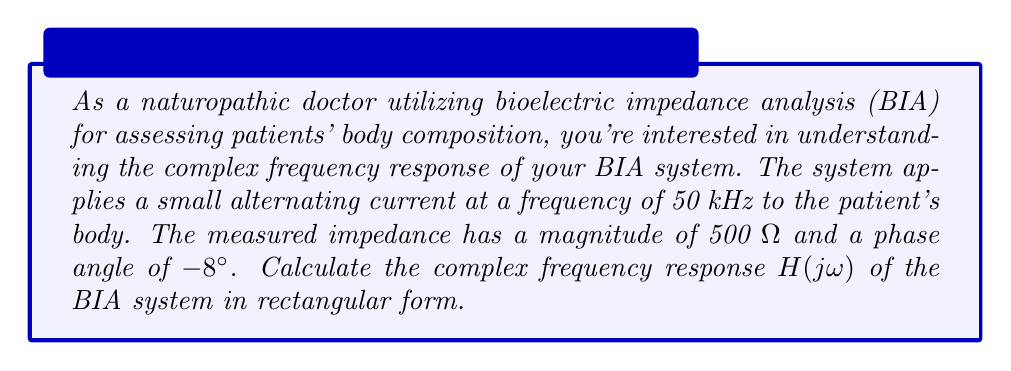Provide a solution to this math problem. To solve this problem, we'll follow these steps:

1) The complex frequency response H(jω) is essentially the same as the measured impedance in this case.

2) We're given the magnitude and phase angle of the impedance. This is in polar form, and we need to convert it to rectangular form.

3) The general form for converting from polar to rectangular is:

   $$ z = r(\cos\theta + j\sin\theta) $$

   where $r$ is the magnitude and $\theta$ is the phase angle.

4) In our case:
   $r = 500$ Ω
   $\theta = -8°$

5) We need to convert the angle from degrees to radians:
   $$ -8° \times \frac{\pi}{180°} = -0.1396 \text{ radians} $$

6) Now we can apply the conversion formula:

   $$ H(j\omega) = 500(\cos(-0.1396) + j\sin(-0.1396)) $$

7) Calculate the cosine and sine:
   $\cos(-0.1396) \approx 0.9903$
   $\sin(-0.1396) \approx -0.1392$

8) Substitute these values:

   $$ H(j\omega) = 500(0.9903 - j0.1392) $$

9) Multiply through:

   $$ H(j\omega) = 495.15 - j69.6 $$

This is our final answer in rectangular form.
Answer: $$ H(j\omega) = 495.15 - j69.6 \text{ Ω} $$ 